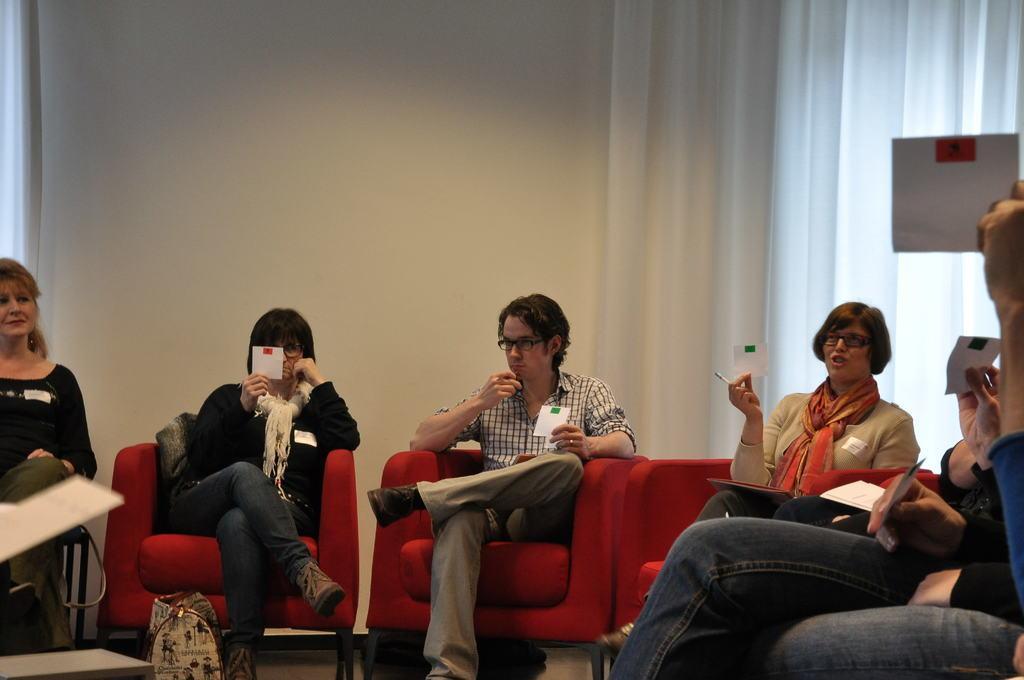How would you summarize this image in a sentence or two? This picture shows a group of people seated on the chairs holding papers in their hands and we see a bag on the floor and we see curtain to the window and a white background wall 